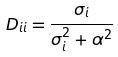Convert formula to latex. <formula><loc_0><loc_0><loc_500><loc_500>D _ { i i } = \frac { \sigma _ { i } } { \sigma _ { i } ^ { 2 } + \alpha ^ { 2 } }</formula> 